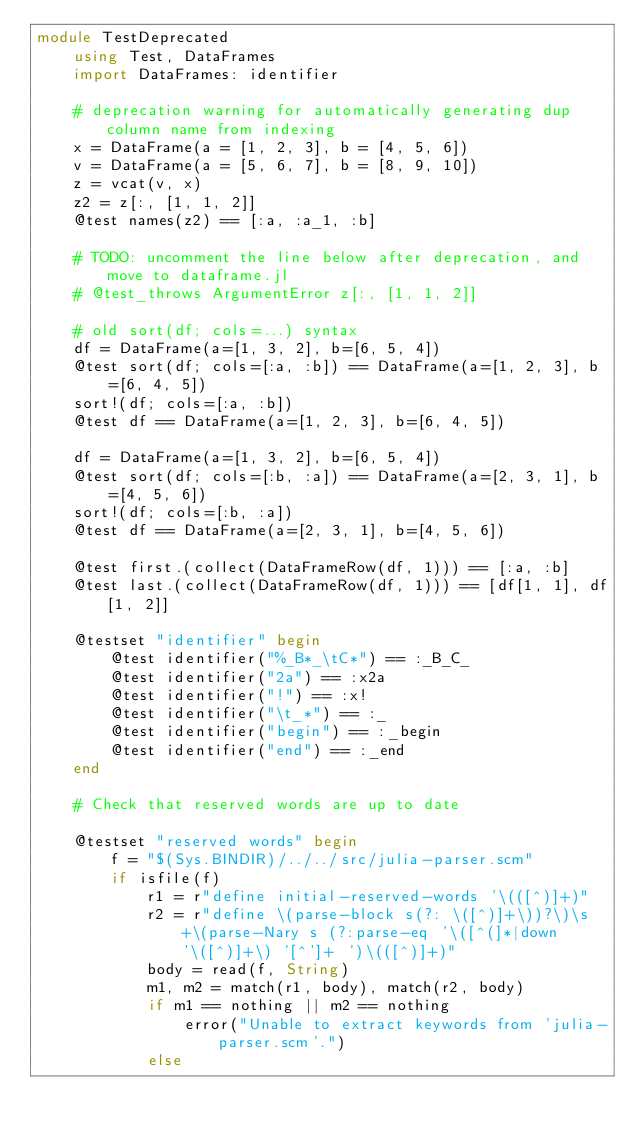<code> <loc_0><loc_0><loc_500><loc_500><_Julia_>module TestDeprecated
    using Test, DataFrames
    import DataFrames: identifier

    # deprecation warning for automatically generating dup column name from indexing
    x = DataFrame(a = [1, 2, 3], b = [4, 5, 6])
    v = DataFrame(a = [5, 6, 7], b = [8, 9, 10])
    z = vcat(v, x)
    z2 = z[:, [1, 1, 2]]
    @test names(z2) == [:a, :a_1, :b]

    # TODO: uncomment the line below after deprecation, and move to dataframe.jl
    # @test_throws ArgumentError z[:, [1, 1, 2]]

    # old sort(df; cols=...) syntax
    df = DataFrame(a=[1, 3, 2], b=[6, 5, 4])
    @test sort(df; cols=[:a, :b]) == DataFrame(a=[1, 2, 3], b=[6, 4, 5])
    sort!(df; cols=[:a, :b])
    @test df == DataFrame(a=[1, 2, 3], b=[6, 4, 5])

    df = DataFrame(a=[1, 3, 2], b=[6, 5, 4])
    @test sort(df; cols=[:b, :a]) == DataFrame(a=[2, 3, 1], b=[4, 5, 6])
    sort!(df; cols=[:b, :a])
    @test df == DataFrame(a=[2, 3, 1], b=[4, 5, 6])

    @test first.(collect(DataFrameRow(df, 1))) == [:a, :b]
    @test last.(collect(DataFrameRow(df, 1))) == [df[1, 1], df[1, 2]]

    @testset "identifier" begin
        @test identifier("%_B*_\tC*") == :_B_C_
        @test identifier("2a") == :x2a
        @test identifier("!") == :x!
        @test identifier("\t_*") == :_
        @test identifier("begin") == :_begin
        @test identifier("end") == :_end
    end

    # Check that reserved words are up to date

    @testset "reserved words" begin
        f = "$(Sys.BINDIR)/../../src/julia-parser.scm"
        if isfile(f)
            r1 = r"define initial-reserved-words '\(([^)]+)"
            r2 = r"define \(parse-block s(?: \([^)]+\))?\)\s+\(parse-Nary s (?:parse-eq '\([^(]*|down '\([^)]+\) '[^']+ ')\(([^)]+)"
            body = read(f, String)
            m1, m2 = match(r1, body), match(r2, body)
            if m1 == nothing || m2 == nothing
                error("Unable to extract keywords from 'julia-parser.scm'.")
            else</code> 